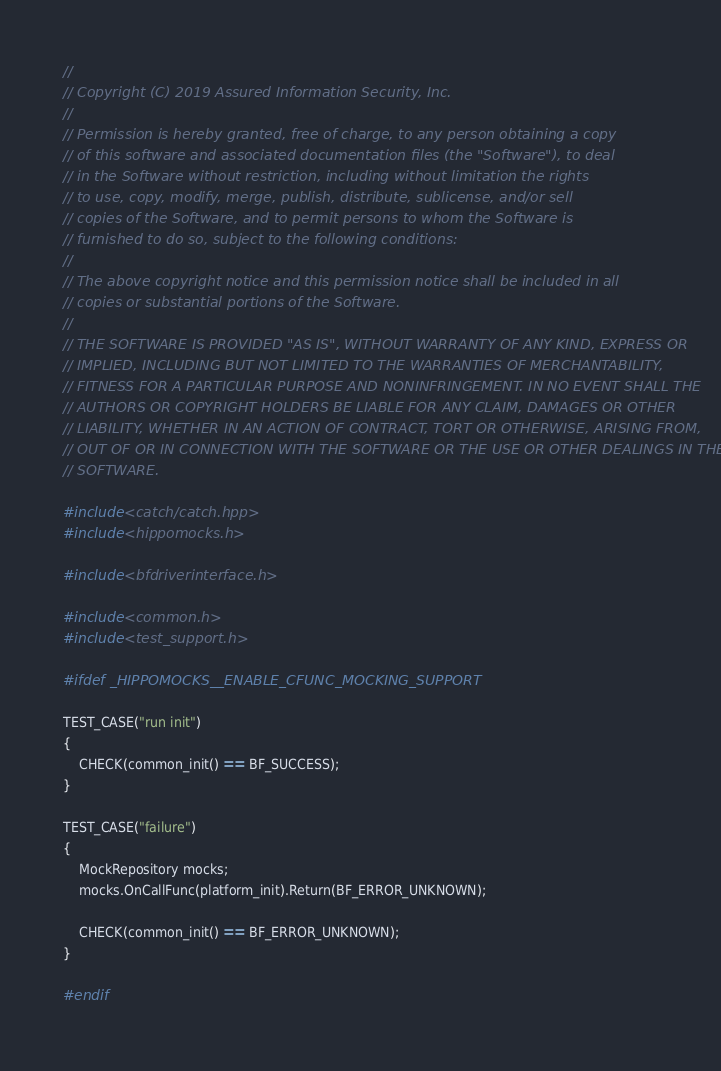<code> <loc_0><loc_0><loc_500><loc_500><_C++_>//
// Copyright (C) 2019 Assured Information Security, Inc.
//
// Permission is hereby granted, free of charge, to any person obtaining a copy
// of this software and associated documentation files (the "Software"), to deal
// in the Software without restriction, including without limitation the rights
// to use, copy, modify, merge, publish, distribute, sublicense, and/or sell
// copies of the Software, and to permit persons to whom the Software is
// furnished to do so, subject to the following conditions:
//
// The above copyright notice and this permission notice shall be included in all
// copies or substantial portions of the Software.
//
// THE SOFTWARE IS PROVIDED "AS IS", WITHOUT WARRANTY OF ANY KIND, EXPRESS OR
// IMPLIED, INCLUDING BUT NOT LIMITED TO THE WARRANTIES OF MERCHANTABILITY,
// FITNESS FOR A PARTICULAR PURPOSE AND NONINFRINGEMENT. IN NO EVENT SHALL THE
// AUTHORS OR COPYRIGHT HOLDERS BE LIABLE FOR ANY CLAIM, DAMAGES OR OTHER
// LIABILITY, WHETHER IN AN ACTION OF CONTRACT, TORT OR OTHERWISE, ARISING FROM,
// OUT OF OR IN CONNECTION WITH THE SOFTWARE OR THE USE OR OTHER DEALINGS IN THE
// SOFTWARE.

#include <catch/catch.hpp>
#include <hippomocks.h>

#include <bfdriverinterface.h>

#include <common.h>
#include <test_support.h>

#ifdef _HIPPOMOCKS__ENABLE_CFUNC_MOCKING_SUPPORT

TEST_CASE("run init")
{
    CHECK(common_init() == BF_SUCCESS);
}

TEST_CASE("failure")
{
    MockRepository mocks;
    mocks.OnCallFunc(platform_init).Return(BF_ERROR_UNKNOWN);

    CHECK(common_init() == BF_ERROR_UNKNOWN);
}

#endif
</code> 